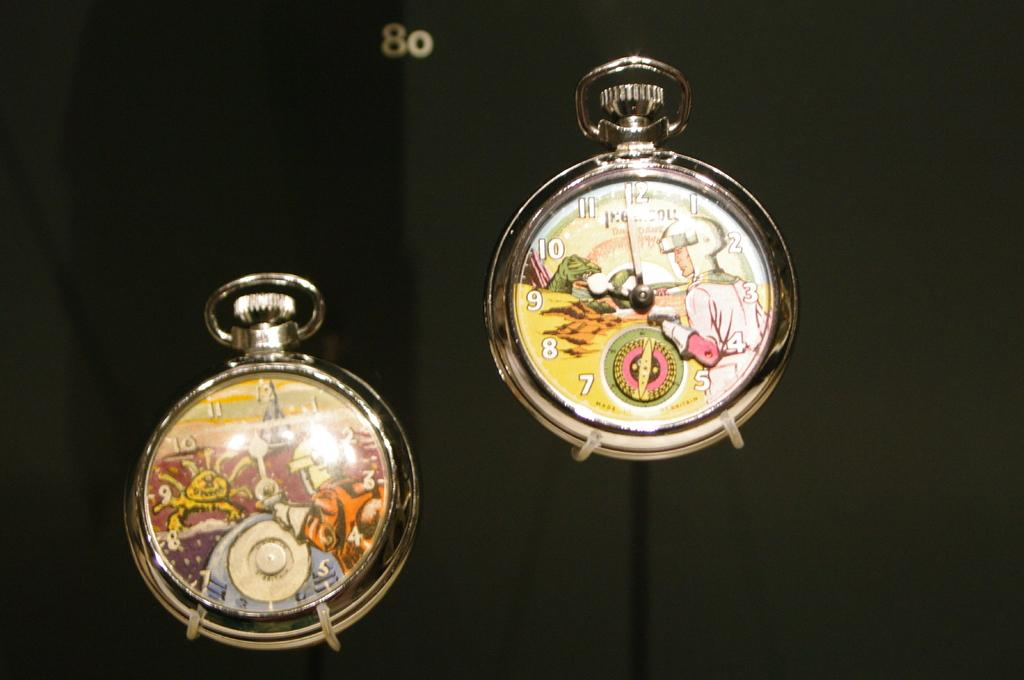<image>
Give a short and clear explanation of the subsequent image. Two watches are shown with colorful faces and the number 80 above. 